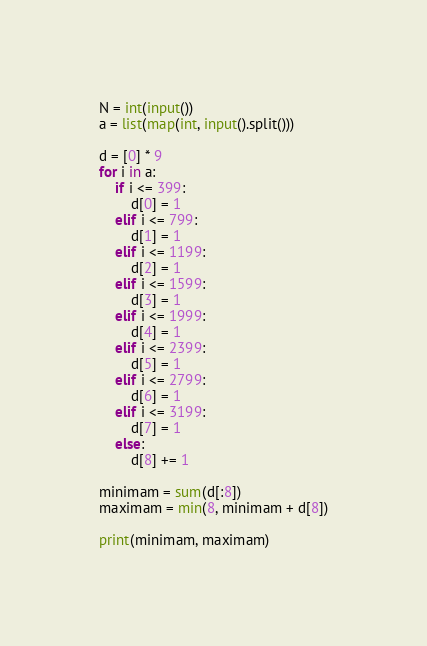<code> <loc_0><loc_0><loc_500><loc_500><_Python_>N = int(input())
a = list(map(int, input().split()))

d = [0] * 9
for i in a:
    if i <= 399:
        d[0] = 1
    elif i <= 799:
        d[1] = 1
    elif i <= 1199:
        d[2] = 1
    elif i <= 1599:
        d[3] = 1
    elif i <= 1999:
        d[4] = 1
    elif i <= 2399:
        d[5] = 1
    elif i <= 2799:
        d[6] = 1
    elif i <= 3199:
        d[7] = 1
    else:
        d[8] += 1

minimam = sum(d[:8])
maximam = min(8, minimam + d[8])

print(minimam, maximam)
</code> 